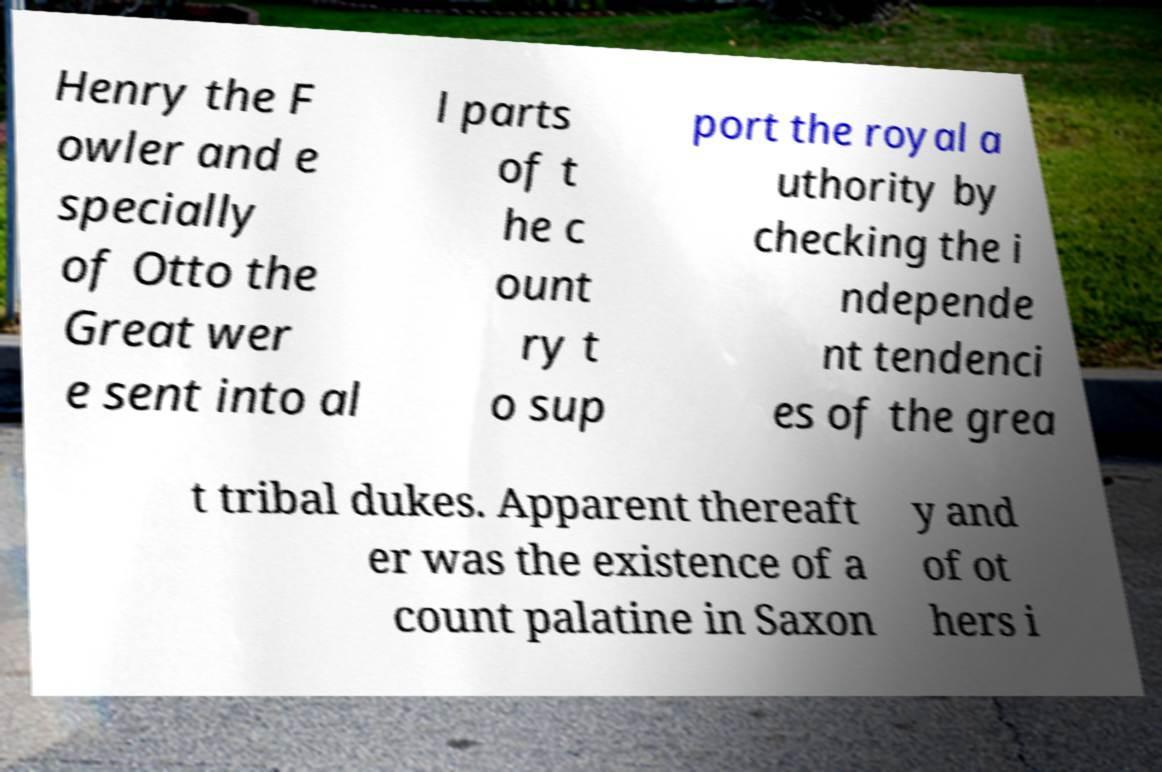There's text embedded in this image that I need extracted. Can you transcribe it verbatim? Henry the F owler and e specially of Otto the Great wer e sent into al l parts of t he c ount ry t o sup port the royal a uthority by checking the i ndepende nt tendenci es of the grea t tribal dukes. Apparent thereaft er was the existence of a count palatine in Saxon y and of ot hers i 